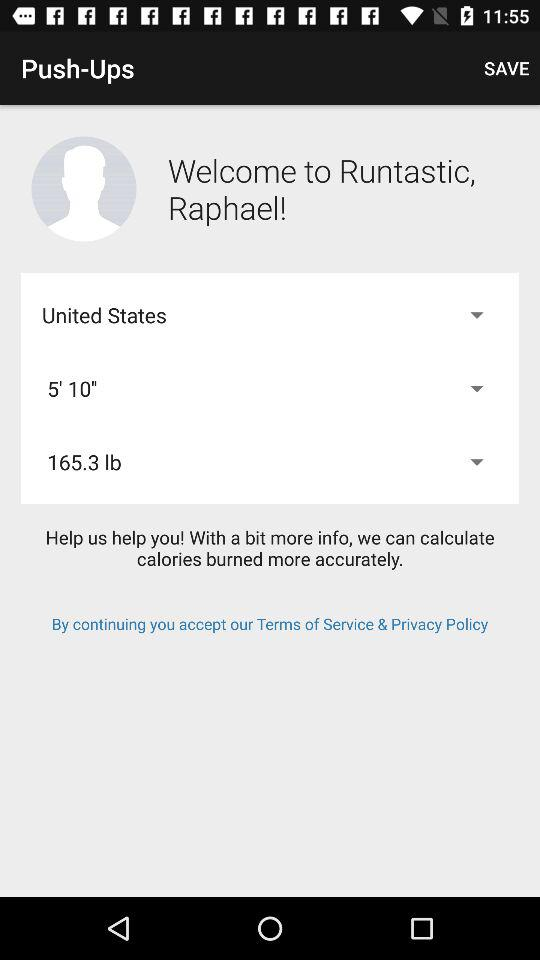Which country is selected? The selected country is the United States. 